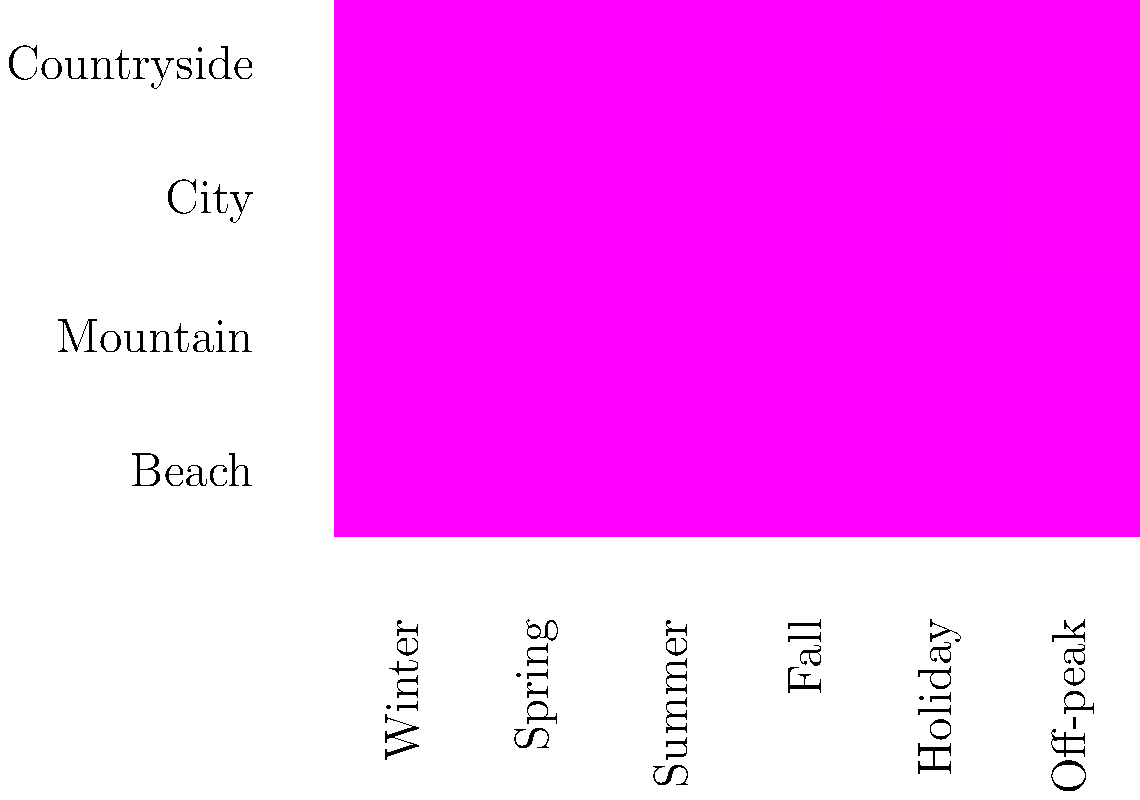Based on the heat map of travel destinations and seasons, which combination would be most beneficial for implementing dynamic pricing in the company's scheduling software, considering both high demand and potential for off-peak discounts? To determine the most beneficial combination for dynamic pricing, we need to analyze the heat map for both high-demand periods and off-peak seasons:

1. Identify high-demand periods:
   - Beach destinations are most popular in Summer
   - Mountain destinations are popular in Summer and Winter
   - City destinations are popular in Spring and Summer
   - Countryside is most popular in Summer and Fall

2. Identify off-peak seasons:
   - Beach destinations have low demand in Winter
   - Mountain destinations have low demand in Fall
   - City destinations have low demand in Winter
   - Countryside has low demand in Winter

3. Consider the combination of high demand and off-peak potential:
   - Beach destinations offer the most stark contrast between peak (Summer) and off-peak (Winter) seasons
   - This allows for significant price adjustments between seasons

4. Evaluate the impact on scheduling software:
   - Implementing dynamic pricing for beach destinations would require the most flexible pricing model
   - It would also demonstrate the software's capability to handle extreme seasonal variations

5. Potential for maximizing revenue:
   - High prices during peak Summer months for beach destinations
   - Attractive discounts during Winter months to encourage off-season travel

Therefore, focusing on beach destinations with their Summer peak and Winter off-peak would be most beneficial for showcasing dynamic pricing capabilities in the scheduling software.
Answer: Beach destinations (Summer peak, Winter off-peak) 